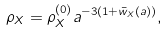<formula> <loc_0><loc_0><loc_500><loc_500>\rho _ { X } = \rho _ { X } ^ { ( 0 ) } a ^ { - 3 ( 1 + \bar { w } _ { X } ( a ) ) } ,</formula> 